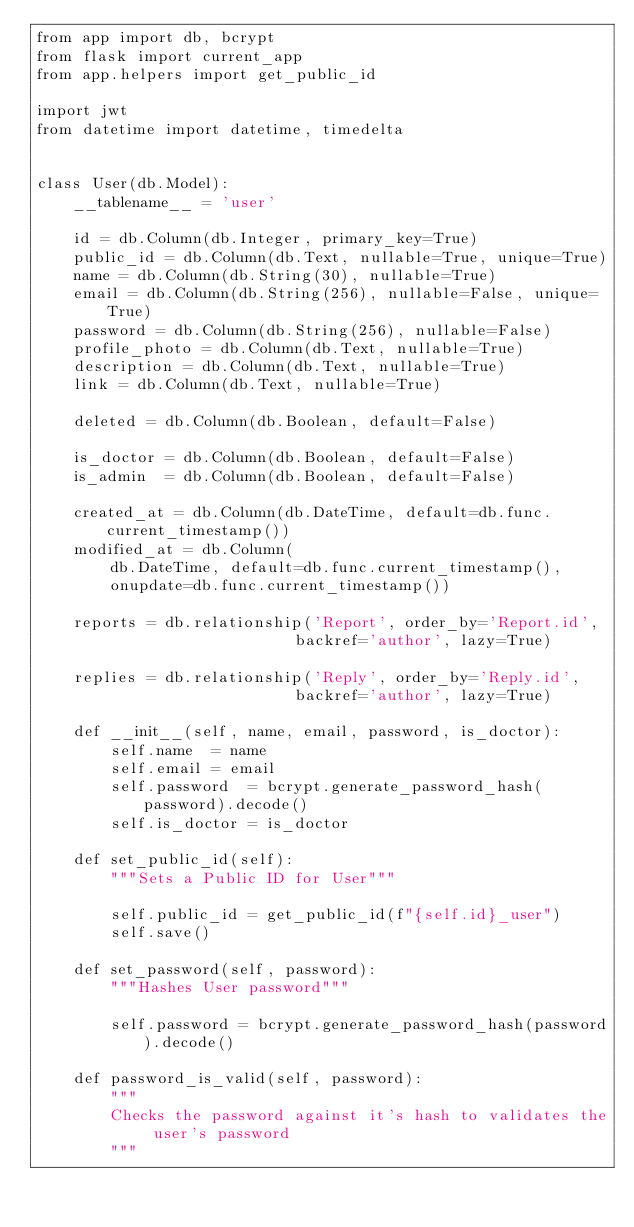Convert code to text. <code><loc_0><loc_0><loc_500><loc_500><_Python_>from app import db, bcrypt
from flask import current_app
from app.helpers import get_public_id

import jwt
from datetime import datetime, timedelta


class User(db.Model):
    __tablename__ = 'user'

    id = db.Column(db.Integer, primary_key=True)
    public_id = db.Column(db.Text, nullable=True, unique=True)
    name = db.Column(db.String(30), nullable=True)
    email = db.Column(db.String(256), nullable=False, unique=True)
    password = db.Column(db.String(256), nullable=False)
    profile_photo = db.Column(db.Text, nullable=True)
    description = db.Column(db.Text, nullable=True)
    link = db.Column(db.Text, nullable=True)

    deleted = db.Column(db.Boolean, default=False)

    is_doctor = db.Column(db.Boolean, default=False)
    is_admin  = db.Column(db.Boolean, default=False)

    created_at = db.Column(db.DateTime, default=db.func.current_timestamp())
    modified_at = db.Column(
        db.DateTime, default=db.func.current_timestamp(),
        onupdate=db.func.current_timestamp())

    reports = db.relationship('Report', order_by='Report.id',
                            backref='author', lazy=True)

    replies = db.relationship('Reply', order_by='Reply.id',
                            backref='author', lazy=True)

    def __init__(self, name, email, password, is_doctor):
        self.name  = name
        self.email = email
        self.password  = bcrypt.generate_password_hash(password).decode()
        self.is_doctor = is_doctor

    def set_public_id(self):
        """Sets a Public ID for User"""

        self.public_id = get_public_id(f"{self.id}_user")
        self.save()

    def set_password(self, password):
        """Hashes User password"""

        self.password = bcrypt.generate_password_hash(password).decode()

    def password_is_valid(self, password):
        """
        Checks the password against it's hash to validates the user's password
        """</code> 